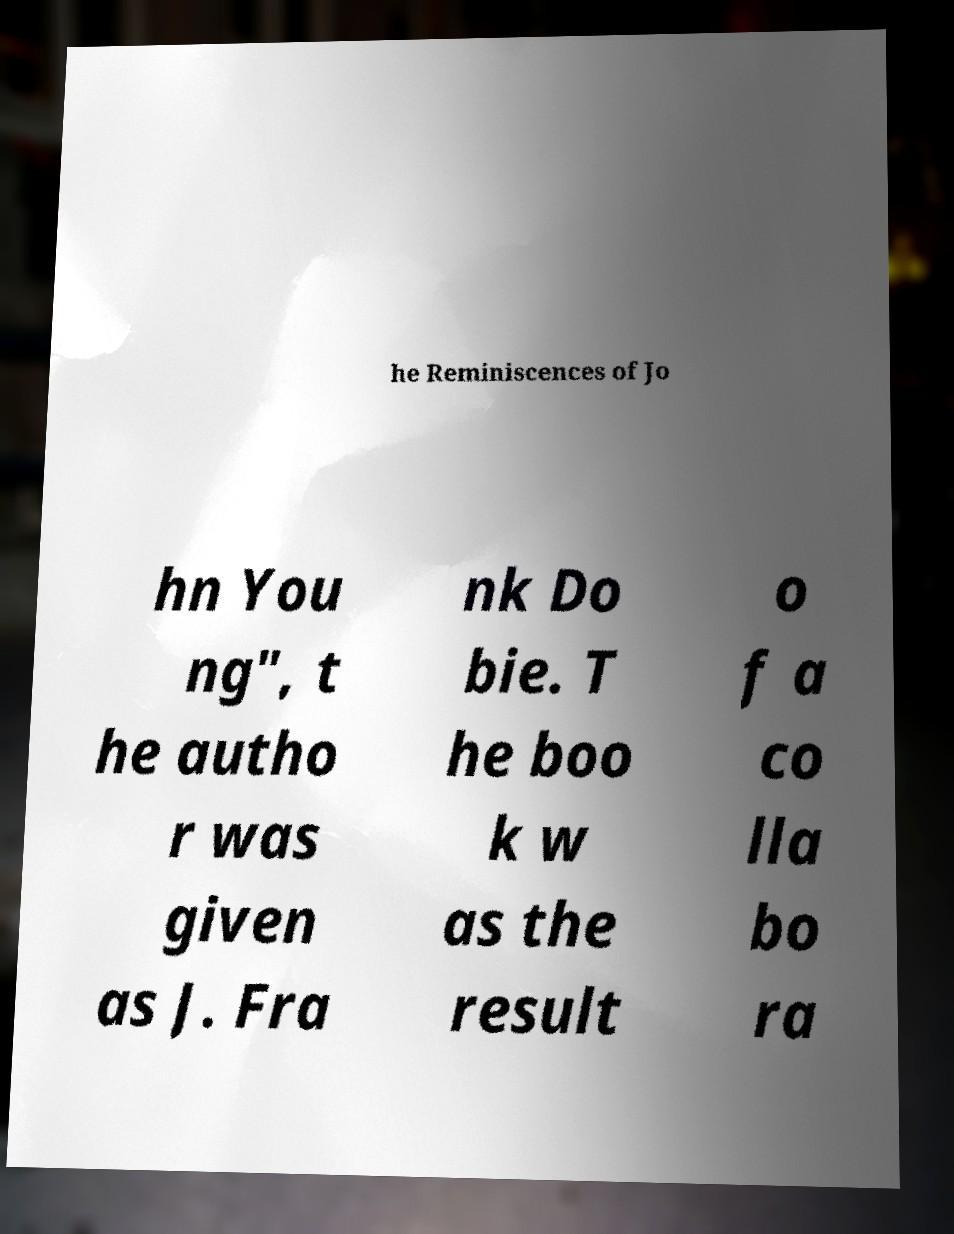Please identify and transcribe the text found in this image. he Reminiscences of Jo hn You ng", t he autho r was given as J. Fra nk Do bie. T he boo k w as the result o f a co lla bo ra 